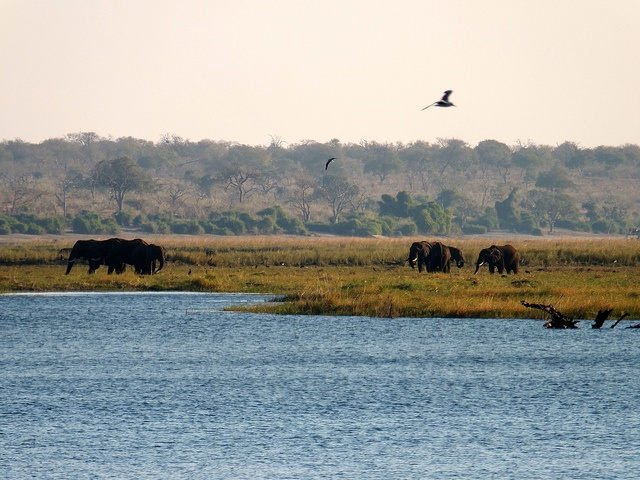Describe the objects in this image and their specific colors. I can see elephant in ivory, black, gray, and maroon tones, elephant in ivory, black, olive, and tan tones, elephant in ivory, black, maroon, and gray tones, elephant in ivory, black, gray, and maroon tones, and elephant in ivory, black, olive, and gray tones in this image. 